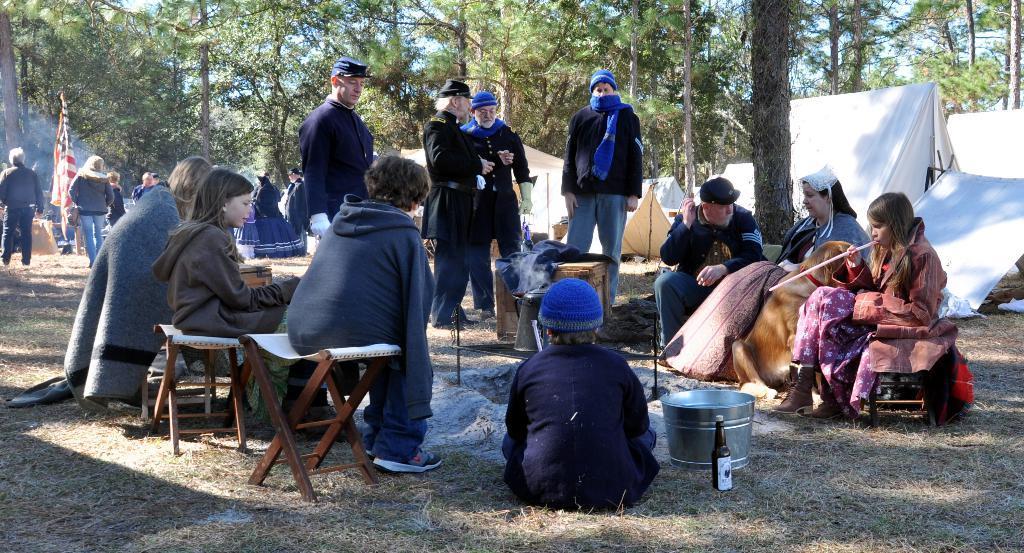Please provide a concise description of this image. This is an outside view. Here I can see few people are sitting on the chairs, few are sitting on the floor and few are standing. In the background I can see trees and white color tents. Everyone are wearing jackets. On the right side there is a dog. 